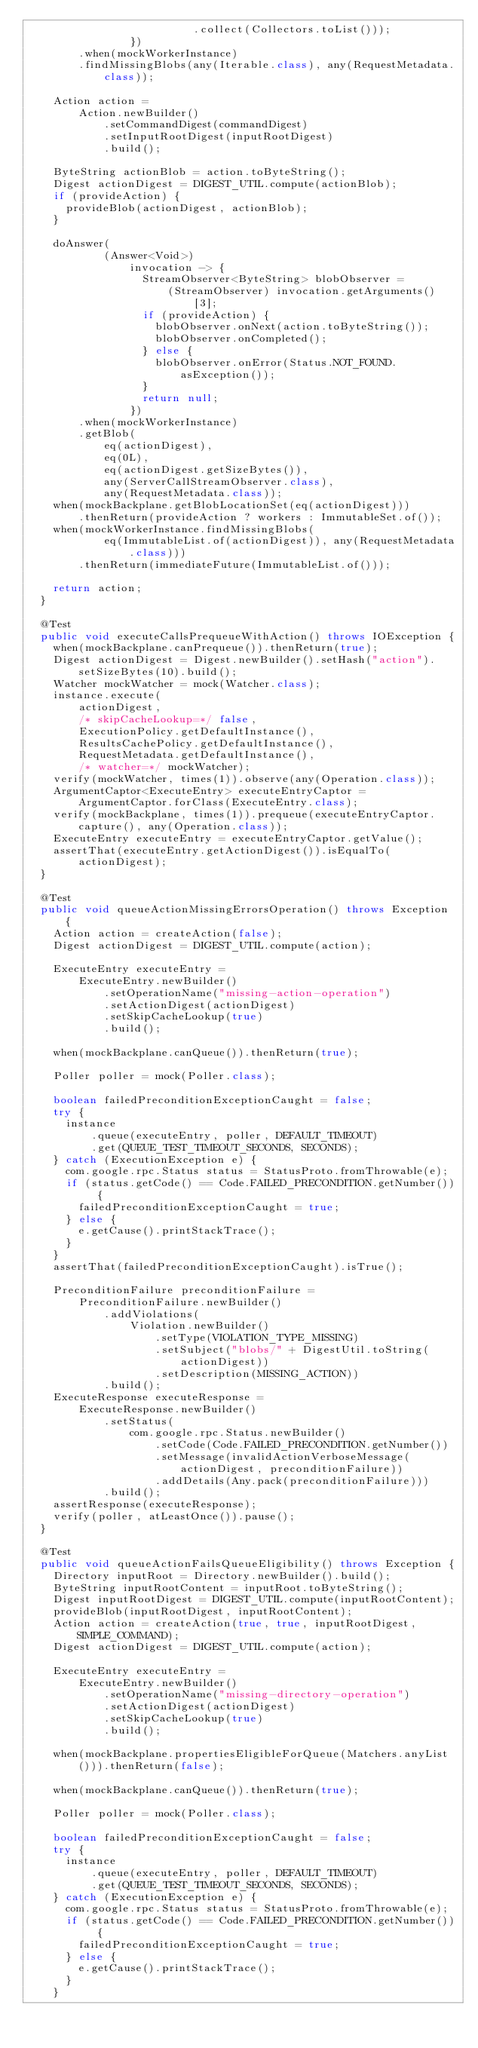Convert code to text. <code><loc_0><loc_0><loc_500><loc_500><_Java_>                          .collect(Collectors.toList()));
                })
        .when(mockWorkerInstance)
        .findMissingBlobs(any(Iterable.class), any(RequestMetadata.class));

    Action action =
        Action.newBuilder()
            .setCommandDigest(commandDigest)
            .setInputRootDigest(inputRootDigest)
            .build();

    ByteString actionBlob = action.toByteString();
    Digest actionDigest = DIGEST_UTIL.compute(actionBlob);
    if (provideAction) {
      provideBlob(actionDigest, actionBlob);
    }

    doAnswer(
            (Answer<Void>)
                invocation -> {
                  StreamObserver<ByteString> blobObserver =
                      (StreamObserver) invocation.getArguments()[3];
                  if (provideAction) {
                    blobObserver.onNext(action.toByteString());
                    blobObserver.onCompleted();
                  } else {
                    blobObserver.onError(Status.NOT_FOUND.asException());
                  }
                  return null;
                })
        .when(mockWorkerInstance)
        .getBlob(
            eq(actionDigest),
            eq(0L),
            eq(actionDigest.getSizeBytes()),
            any(ServerCallStreamObserver.class),
            any(RequestMetadata.class));
    when(mockBackplane.getBlobLocationSet(eq(actionDigest)))
        .thenReturn(provideAction ? workers : ImmutableSet.of());
    when(mockWorkerInstance.findMissingBlobs(
            eq(ImmutableList.of(actionDigest)), any(RequestMetadata.class)))
        .thenReturn(immediateFuture(ImmutableList.of()));

    return action;
  }

  @Test
  public void executeCallsPrequeueWithAction() throws IOException {
    when(mockBackplane.canPrequeue()).thenReturn(true);
    Digest actionDigest = Digest.newBuilder().setHash("action").setSizeBytes(10).build();
    Watcher mockWatcher = mock(Watcher.class);
    instance.execute(
        actionDigest,
        /* skipCacheLookup=*/ false,
        ExecutionPolicy.getDefaultInstance(),
        ResultsCachePolicy.getDefaultInstance(),
        RequestMetadata.getDefaultInstance(),
        /* watcher=*/ mockWatcher);
    verify(mockWatcher, times(1)).observe(any(Operation.class));
    ArgumentCaptor<ExecuteEntry> executeEntryCaptor = ArgumentCaptor.forClass(ExecuteEntry.class);
    verify(mockBackplane, times(1)).prequeue(executeEntryCaptor.capture(), any(Operation.class));
    ExecuteEntry executeEntry = executeEntryCaptor.getValue();
    assertThat(executeEntry.getActionDigest()).isEqualTo(actionDigest);
  }

  @Test
  public void queueActionMissingErrorsOperation() throws Exception {
    Action action = createAction(false);
    Digest actionDigest = DIGEST_UTIL.compute(action);

    ExecuteEntry executeEntry =
        ExecuteEntry.newBuilder()
            .setOperationName("missing-action-operation")
            .setActionDigest(actionDigest)
            .setSkipCacheLookup(true)
            .build();

    when(mockBackplane.canQueue()).thenReturn(true);

    Poller poller = mock(Poller.class);

    boolean failedPreconditionExceptionCaught = false;
    try {
      instance
          .queue(executeEntry, poller, DEFAULT_TIMEOUT)
          .get(QUEUE_TEST_TIMEOUT_SECONDS, SECONDS);
    } catch (ExecutionException e) {
      com.google.rpc.Status status = StatusProto.fromThrowable(e);
      if (status.getCode() == Code.FAILED_PRECONDITION.getNumber()) {
        failedPreconditionExceptionCaught = true;
      } else {
        e.getCause().printStackTrace();
      }
    }
    assertThat(failedPreconditionExceptionCaught).isTrue();

    PreconditionFailure preconditionFailure =
        PreconditionFailure.newBuilder()
            .addViolations(
                Violation.newBuilder()
                    .setType(VIOLATION_TYPE_MISSING)
                    .setSubject("blobs/" + DigestUtil.toString(actionDigest))
                    .setDescription(MISSING_ACTION))
            .build();
    ExecuteResponse executeResponse =
        ExecuteResponse.newBuilder()
            .setStatus(
                com.google.rpc.Status.newBuilder()
                    .setCode(Code.FAILED_PRECONDITION.getNumber())
                    .setMessage(invalidActionVerboseMessage(actionDigest, preconditionFailure))
                    .addDetails(Any.pack(preconditionFailure)))
            .build();
    assertResponse(executeResponse);
    verify(poller, atLeastOnce()).pause();
  }

  @Test
  public void queueActionFailsQueueEligibility() throws Exception {
    Directory inputRoot = Directory.newBuilder().build();
    ByteString inputRootContent = inputRoot.toByteString();
    Digest inputRootDigest = DIGEST_UTIL.compute(inputRootContent);
    provideBlob(inputRootDigest, inputRootContent);
    Action action = createAction(true, true, inputRootDigest, SIMPLE_COMMAND);
    Digest actionDigest = DIGEST_UTIL.compute(action);

    ExecuteEntry executeEntry =
        ExecuteEntry.newBuilder()
            .setOperationName("missing-directory-operation")
            .setActionDigest(actionDigest)
            .setSkipCacheLookup(true)
            .build();

    when(mockBackplane.propertiesEligibleForQueue(Matchers.anyList())).thenReturn(false);

    when(mockBackplane.canQueue()).thenReturn(true);

    Poller poller = mock(Poller.class);

    boolean failedPreconditionExceptionCaught = false;
    try {
      instance
          .queue(executeEntry, poller, DEFAULT_TIMEOUT)
          .get(QUEUE_TEST_TIMEOUT_SECONDS, SECONDS);
    } catch (ExecutionException e) {
      com.google.rpc.Status status = StatusProto.fromThrowable(e);
      if (status.getCode() == Code.FAILED_PRECONDITION.getNumber()) {
        failedPreconditionExceptionCaught = true;
      } else {
        e.getCause().printStackTrace();
      }
    }</code> 